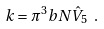<formula> <loc_0><loc_0><loc_500><loc_500>k = \pi ^ { 3 } b N \hat { V } _ { 5 } \ .</formula> 